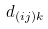Convert formula to latex. <formula><loc_0><loc_0><loc_500><loc_500>d _ { ( i j ) k }</formula> 